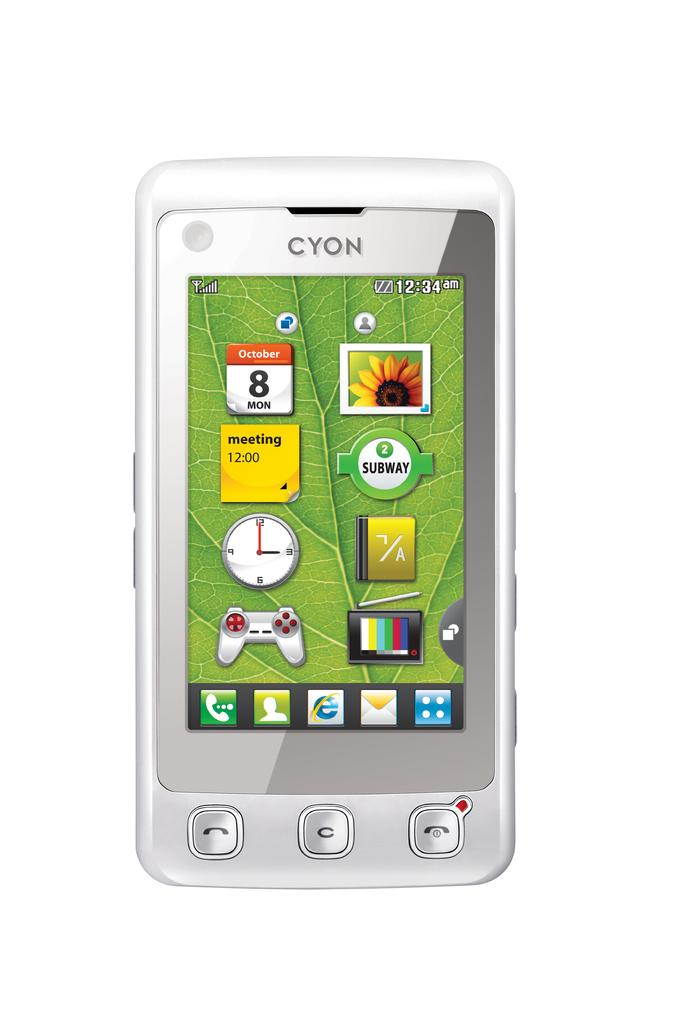<image>
Render a clear and concise summary of the photo. The silver phone shown is made by CYON. 